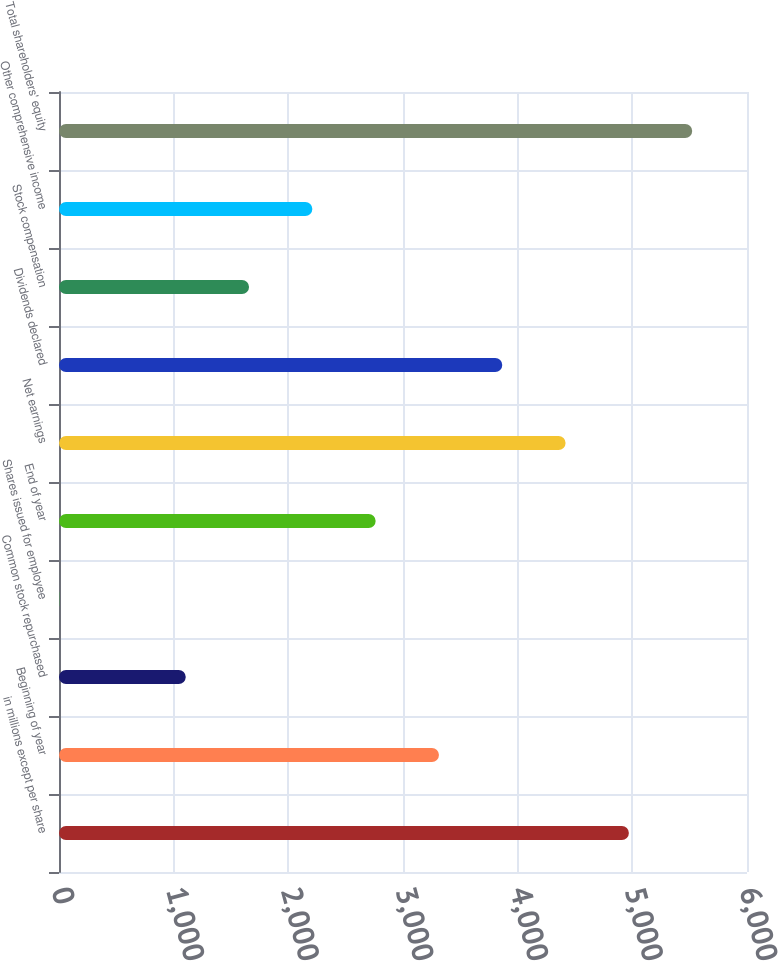Convert chart. <chart><loc_0><loc_0><loc_500><loc_500><bar_chart><fcel>in millions except per share<fcel>Beginning of year<fcel>Common stock repurchased<fcel>Shares issued for employee<fcel>End of year<fcel>Net earnings<fcel>Dividends declared<fcel>Stock compensation<fcel>Other comprehensive income<fcel>Total shareholders' equity<nl><fcel>4969.9<fcel>3313.6<fcel>1105.2<fcel>1<fcel>2761.5<fcel>4417.8<fcel>3865.7<fcel>1657.3<fcel>2209.4<fcel>5522<nl></chart> 